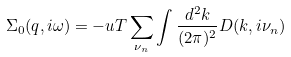<formula> <loc_0><loc_0><loc_500><loc_500>\Sigma _ { 0 } ( q , i \omega ) = - u T \sum _ { \nu _ { n } } \int \frac { d ^ { 2 } k } { ( 2 \pi ) ^ { 2 } } D ( k , i \nu _ { n } )</formula> 